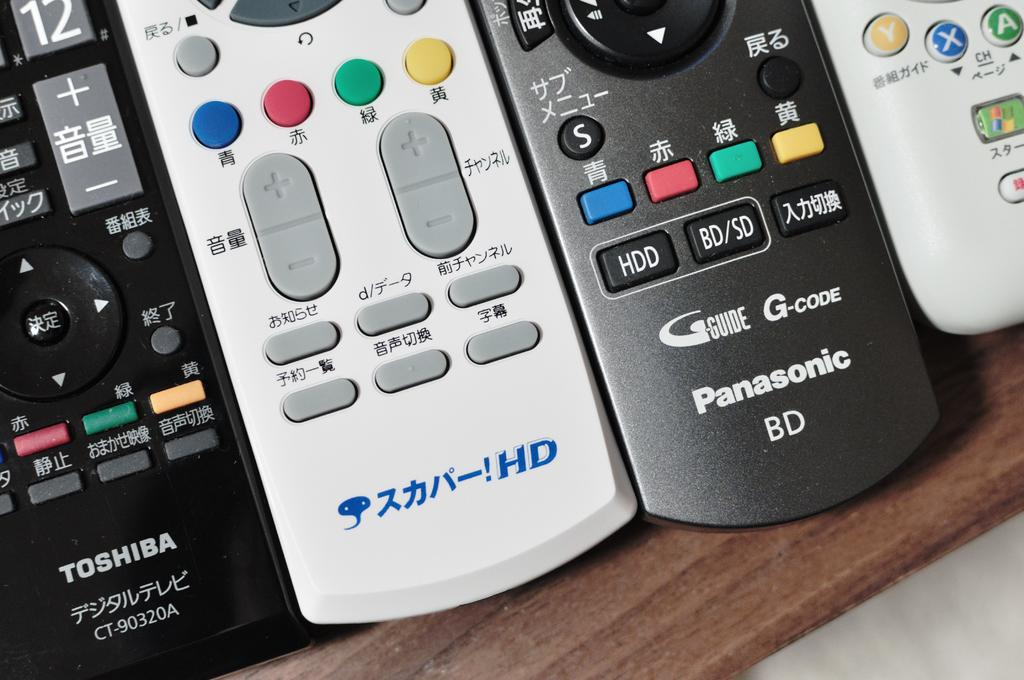<image>
Share a concise interpretation of the image provided. Three remotes are placed next to a black Toshiba remote. 